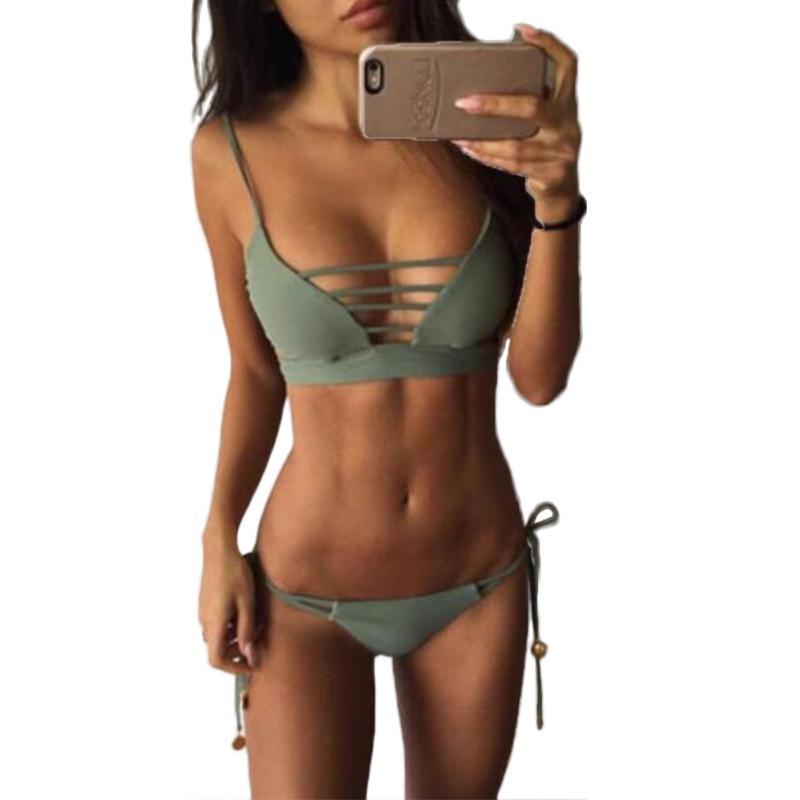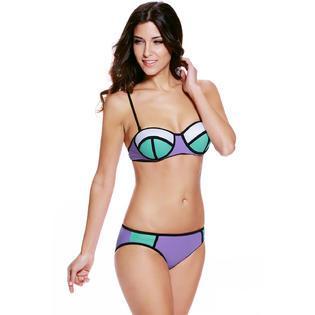The first image is the image on the left, the second image is the image on the right. Evaluate the accuracy of this statement regarding the images: "At least one of the images shows a very low-rise bikini bottom that hits well below the belly button.". Is it true? Answer yes or no. Yes. 